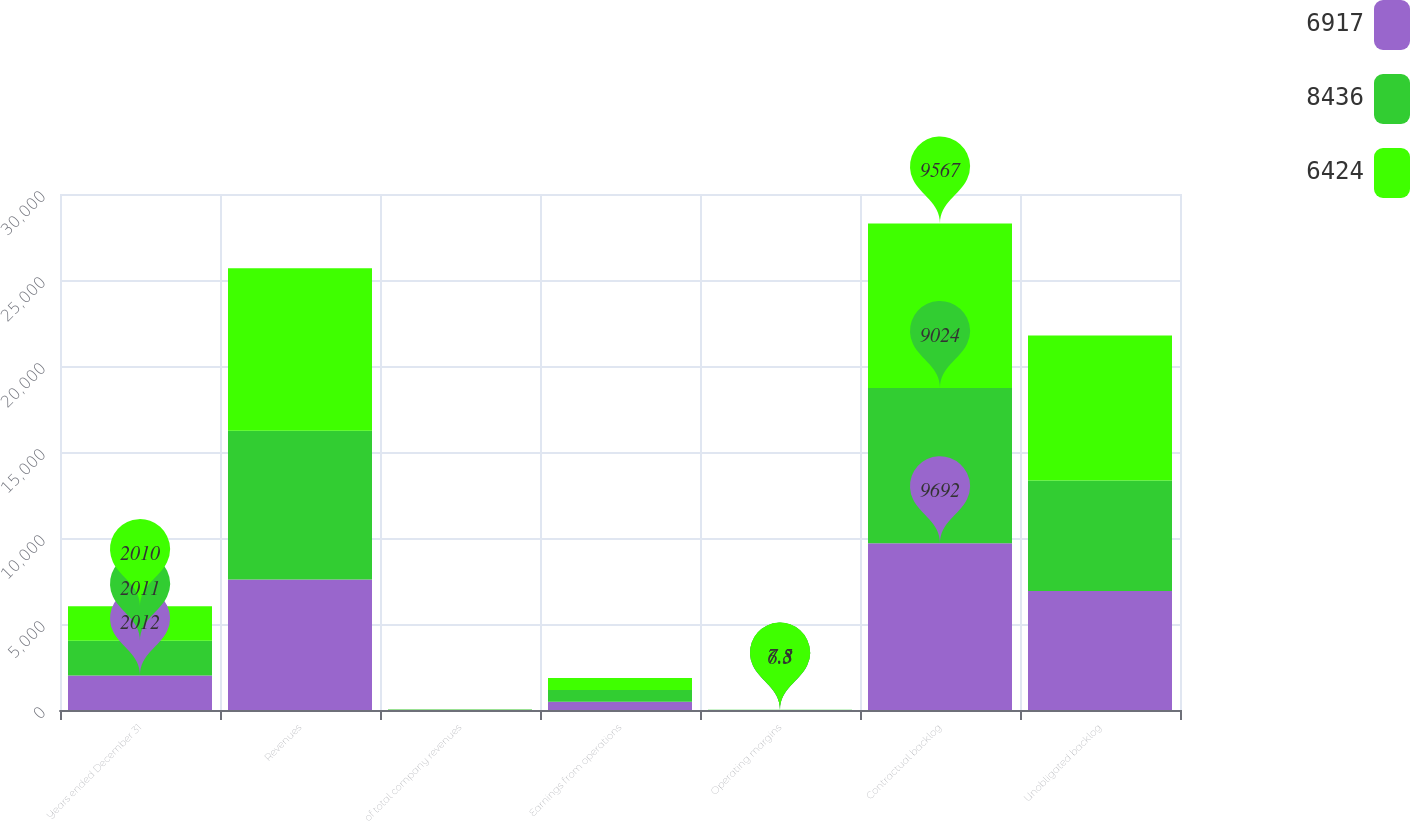Convert chart to OTSL. <chart><loc_0><loc_0><loc_500><loc_500><stacked_bar_chart><ecel><fcel>Years ended December 31<fcel>Revenues<fcel>of total company revenues<fcel>Earnings from operations<fcel>Operating margins<fcel>Contractual backlog<fcel>Unobligated backlog<nl><fcel>6917<fcel>2012<fcel>7584<fcel>9<fcel>478<fcel>6.3<fcel>9692<fcel>6917<nl><fcel>8436<fcel>2011<fcel>8654<fcel>13<fcel>679<fcel>7.8<fcel>9024<fcel>6424<nl><fcel>6424<fcel>2010<fcel>9449<fcel>15<fcel>705<fcel>7.5<fcel>9567<fcel>8436<nl></chart> 